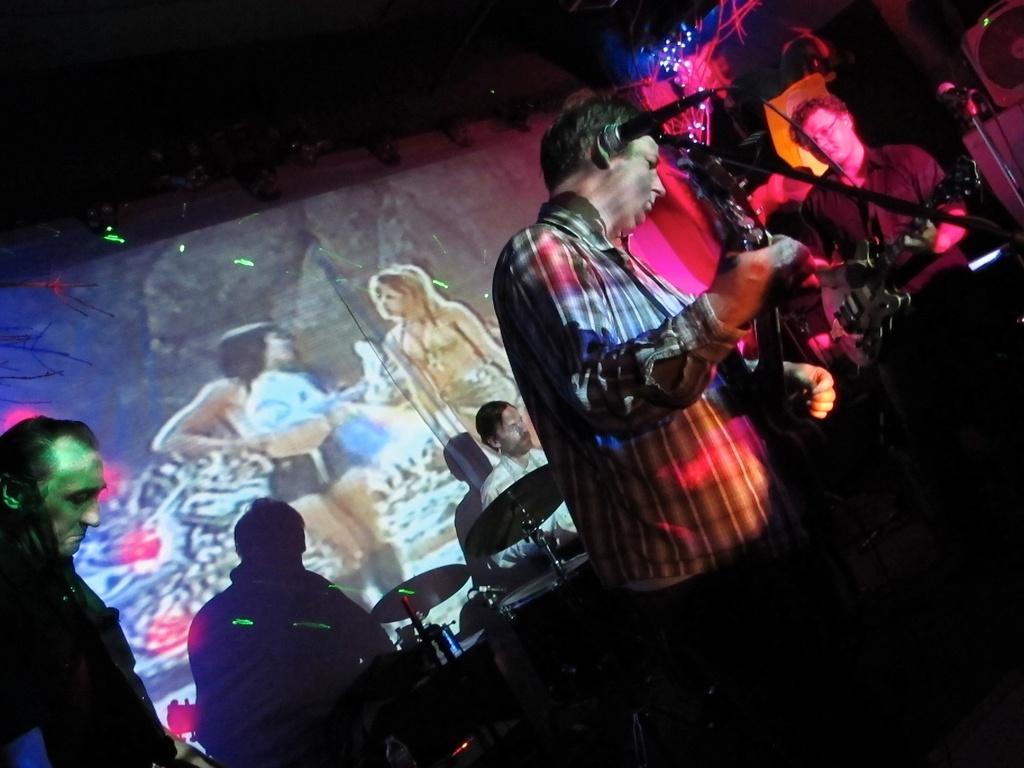Can you describe this image briefly? there is a man holding a guitar and behind and there are few other man holding a musical instruments and two other girl painting on the wall. 